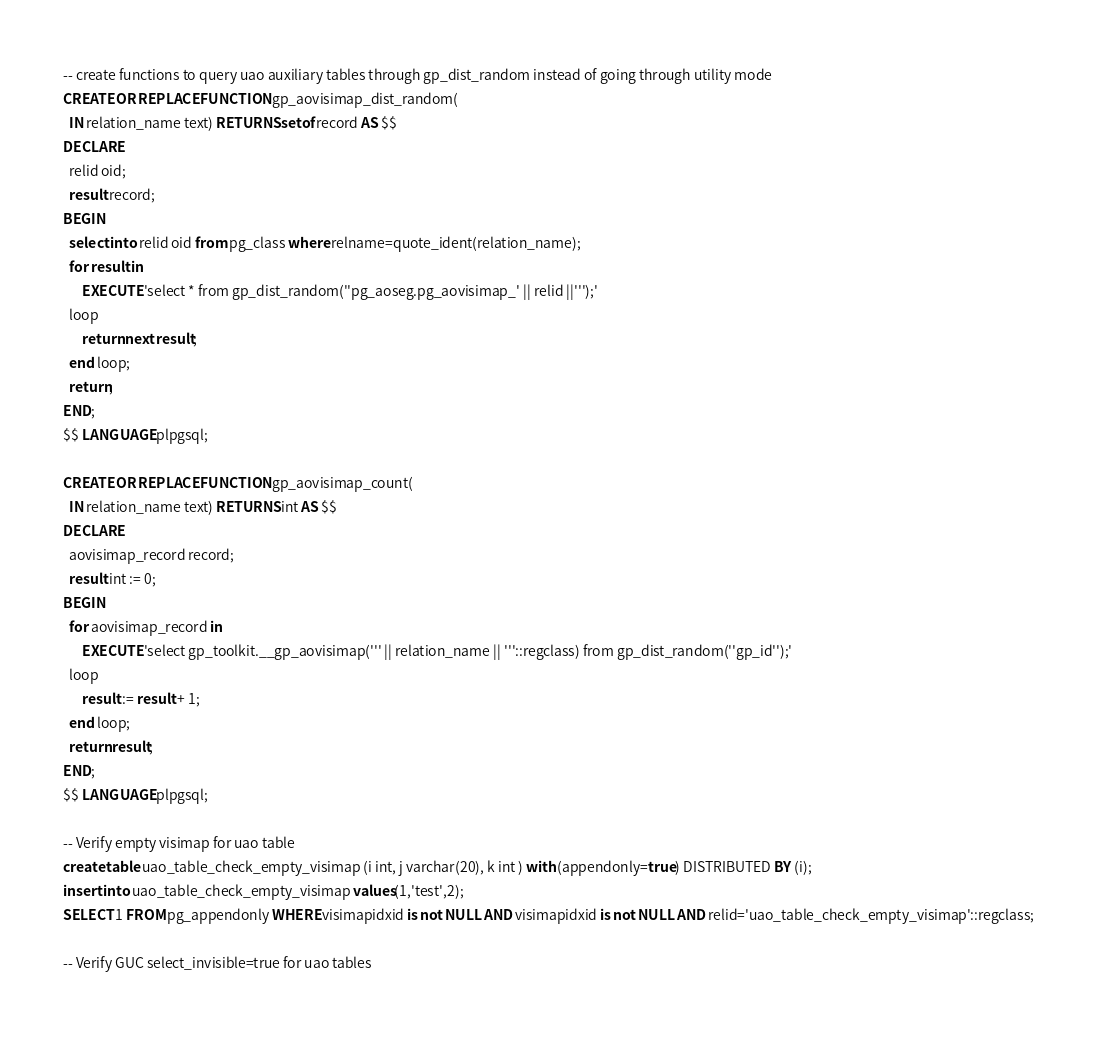<code> <loc_0><loc_0><loc_500><loc_500><_SQL_>-- create functions to query uao auxiliary tables through gp_dist_random instead of going through utility mode
CREATE OR REPLACE FUNCTION gp_aovisimap_dist_random(
  IN relation_name text) RETURNS setof record AS $$
DECLARE
  relid oid;
  result record;
BEGIN
  select into relid oid from pg_class where relname=quote_ident(relation_name);
  for result in
      EXECUTE 'select * from gp_dist_random(''pg_aoseg.pg_aovisimap_' || relid ||''');'
  loop
      return next result;
  end loop;
  return;
END;
$$ LANGUAGE plpgsql;

CREATE OR REPLACE FUNCTION gp_aovisimap_count(
  IN relation_name text) RETURNS int AS $$
DECLARE
  aovisimap_record record;
  result int := 0;
BEGIN
  for aovisimap_record in
      EXECUTE 'select gp_toolkit.__gp_aovisimap(''' || relation_name || '''::regclass) from gp_dist_random(''gp_id'');'
  loop
      result := result + 1;
  end loop;
  return result;
END;
$$ LANGUAGE plpgsql;

-- Verify empty visimap for uao table
create table uao_table_check_empty_visimap (i int, j varchar(20), k int ) with (appendonly=true) DISTRIBUTED BY (i);
insert into uao_table_check_empty_visimap values(1,'test',2);
SELECT 1 FROM pg_appendonly WHERE visimapidxid is not NULL AND visimapidxid is not NULL AND relid='uao_table_check_empty_visimap'::regclass;

-- Verify GUC select_invisible=true for uao tables</code> 